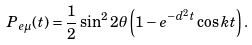Convert formula to latex. <formula><loc_0><loc_0><loc_500><loc_500>P _ { e \mu } ( t ) = \frac { 1 } { 2 } \sin ^ { 2 } 2 \theta \left ( 1 - e ^ { - d ^ { 2 } t } \cos k t \right ) .</formula> 